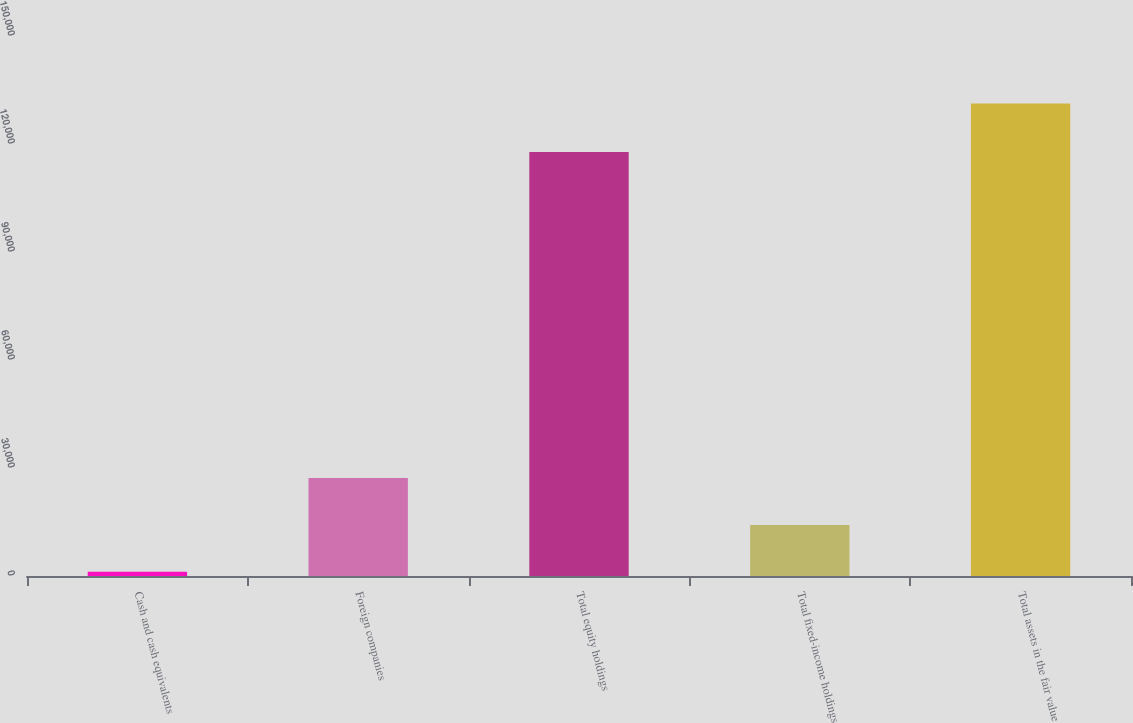Convert chart to OTSL. <chart><loc_0><loc_0><loc_500><loc_500><bar_chart><fcel>Cash and cash equivalents<fcel>Foreign companies<fcel>Total equity holdings<fcel>Total fixed-income holdings<fcel>Total assets in the fair value<nl><fcel>1180<fcel>27188.2<fcel>117779<fcel>14184.1<fcel>131221<nl></chart> 